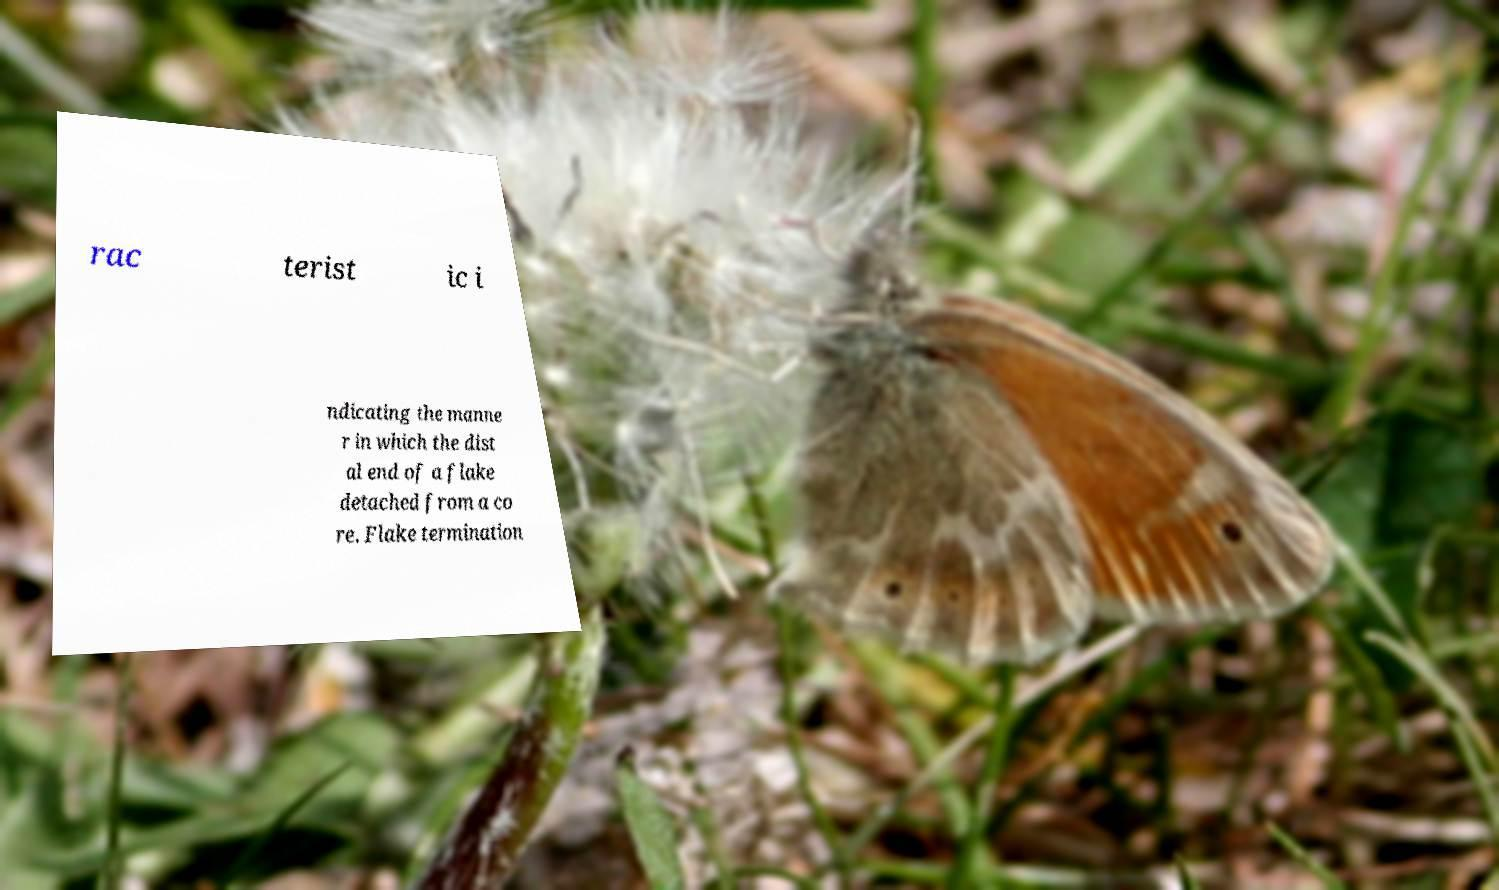Please read and relay the text visible in this image. What does it say? rac terist ic i ndicating the manne r in which the dist al end of a flake detached from a co re. Flake termination 